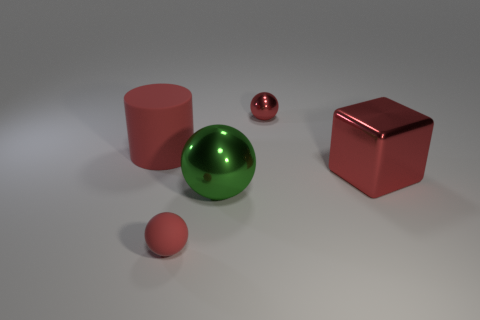Subtract all green blocks. How many red spheres are left? 2 Subtract 1 balls. How many balls are left? 2 Subtract all big green balls. How many balls are left? 2 Add 1 tiny blue cylinders. How many objects exist? 6 Subtract all cylinders. How many objects are left? 4 Add 5 big cubes. How many big cubes are left? 6 Add 2 metallic objects. How many metallic objects exist? 5 Subtract 0 cyan cylinders. How many objects are left? 5 Subtract all small blue rubber cylinders. Subtract all small red shiny things. How many objects are left? 4 